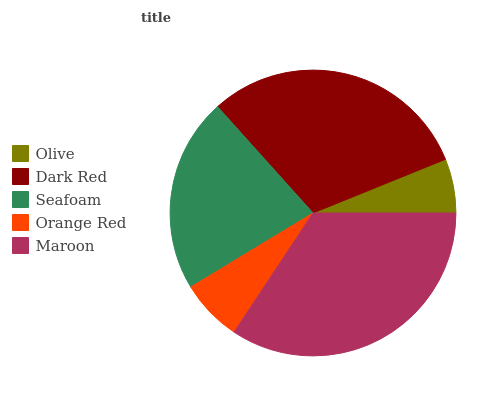Is Olive the minimum?
Answer yes or no. Yes. Is Maroon the maximum?
Answer yes or no. Yes. Is Dark Red the minimum?
Answer yes or no. No. Is Dark Red the maximum?
Answer yes or no. No. Is Dark Red greater than Olive?
Answer yes or no. Yes. Is Olive less than Dark Red?
Answer yes or no. Yes. Is Olive greater than Dark Red?
Answer yes or no. No. Is Dark Red less than Olive?
Answer yes or no. No. Is Seafoam the high median?
Answer yes or no. Yes. Is Seafoam the low median?
Answer yes or no. Yes. Is Orange Red the high median?
Answer yes or no. No. Is Orange Red the low median?
Answer yes or no. No. 